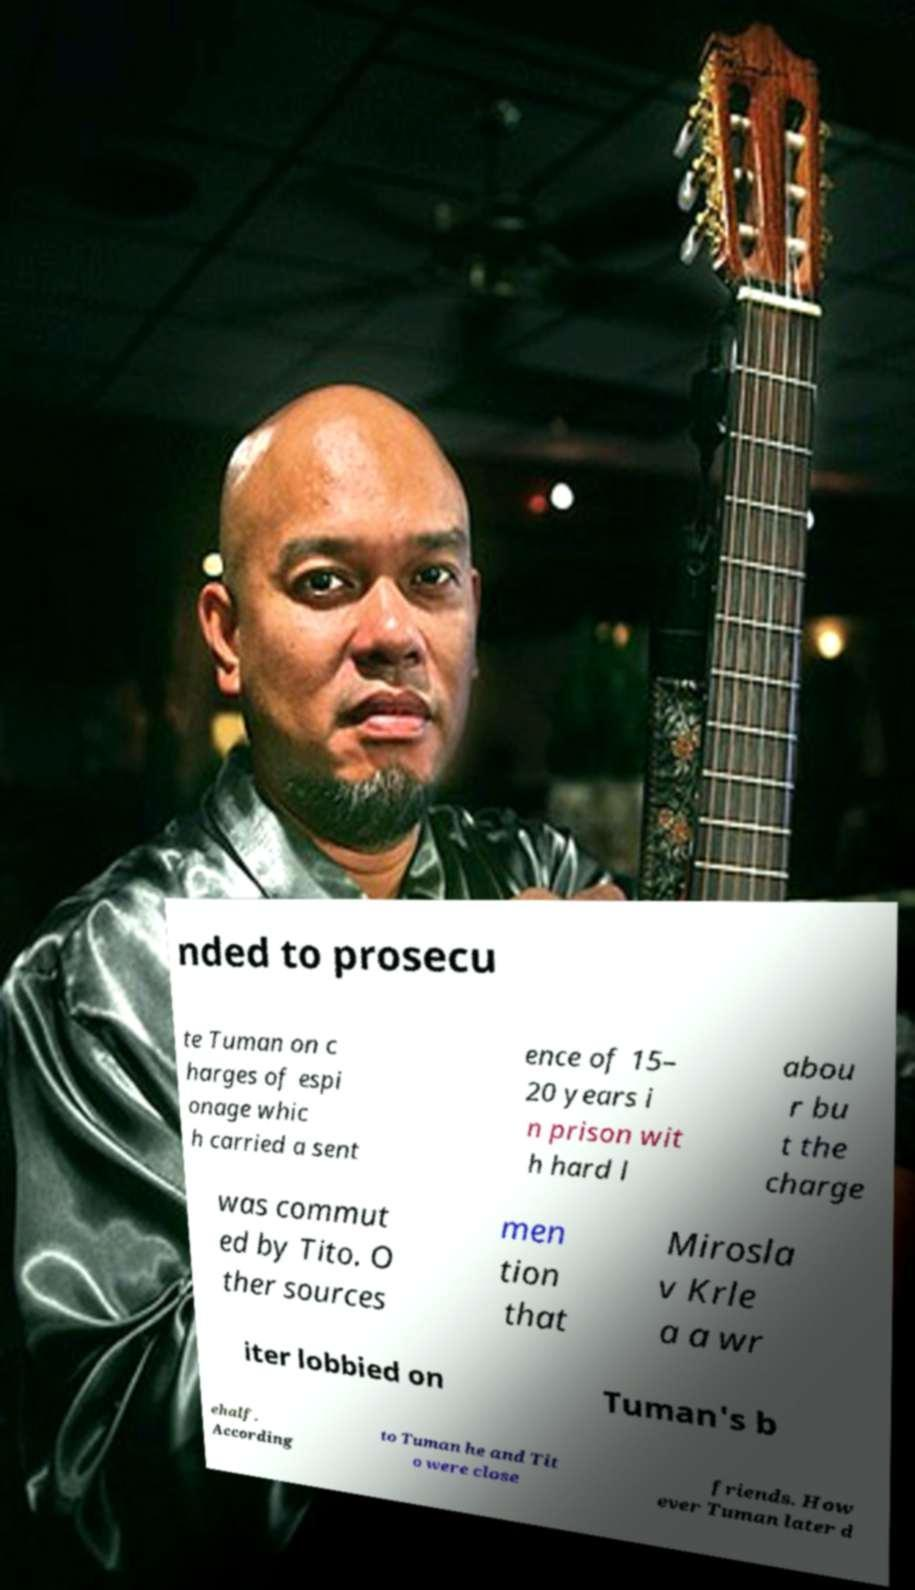For documentation purposes, I need the text within this image transcribed. Could you provide that? nded to prosecu te Tuman on c harges of espi onage whic h carried a sent ence of 15– 20 years i n prison wit h hard l abou r bu t the charge was commut ed by Tito. O ther sources men tion that Mirosla v Krle a a wr iter lobbied on Tuman's b ehalf. According to Tuman he and Tit o were close friends. How ever Tuman later d 